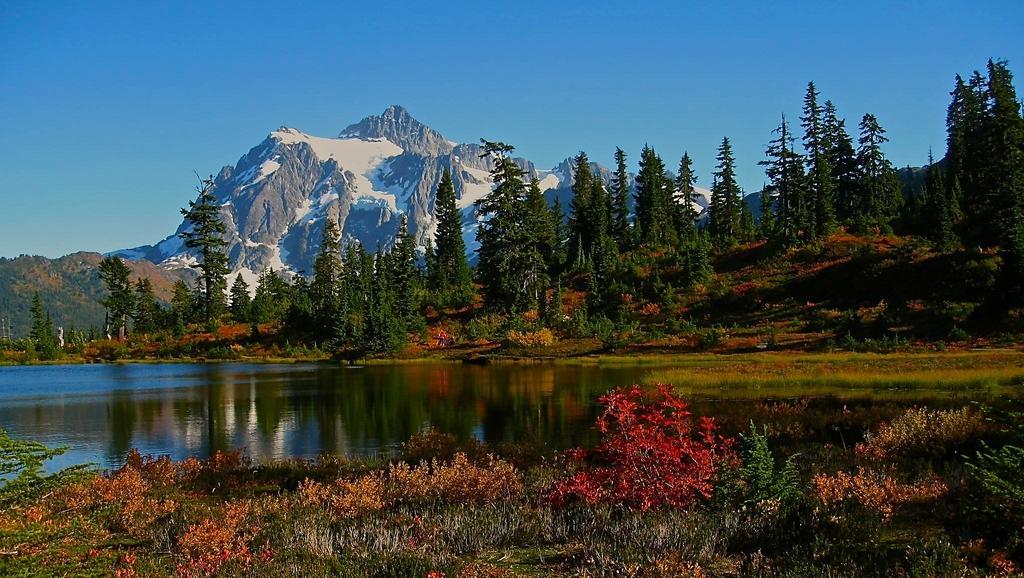Can you describe this image briefly? In the foreground of this image, there are plants. In the middle, there is water. In the background, there are trees, mountains and the sky. 